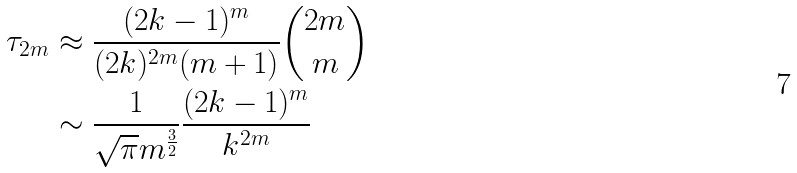<formula> <loc_0><loc_0><loc_500><loc_500>\tau _ { 2 m } & \approx \frac { ( 2 k - 1 ) ^ { m } } { ( 2 k ) ^ { 2 m } ( m + 1 ) } \binom { 2 m } { m } \\ & \sim \frac { 1 } { \sqrt { \pi } m ^ { \frac { 3 } { 2 } } } \frac { ( 2 k - 1 ) ^ { m } } { k ^ { 2 m } }</formula> 